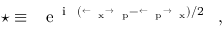Convert formula to latex. <formula><loc_0><loc_0><loc_500><loc_500>^ { * } \equiv { e ^ { i \hbar { ( } \stackrel { \leftarrow } { \partial } _ { x } \stackrel { \rightarrow } { \partial } _ { p } - \stackrel { \leftarrow } { \partial } _ { p } \stackrel { \rightarrow } { \partial } _ { x } ) / 2 } } ,</formula> 